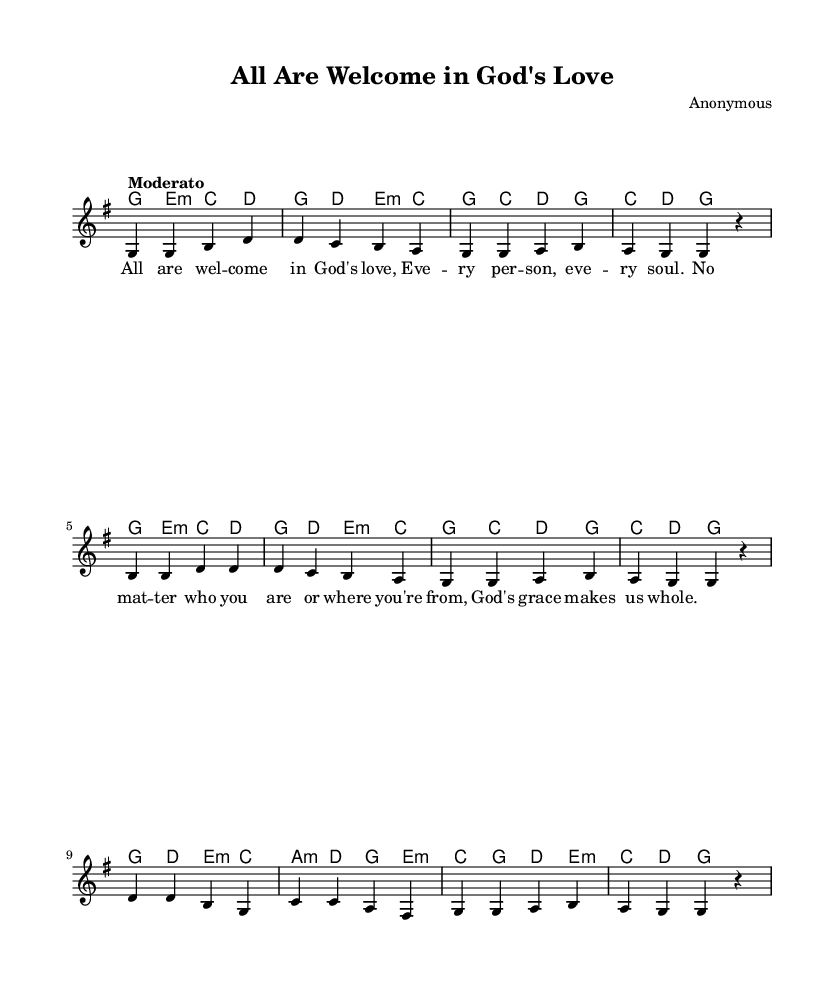What is the key signature of this music? The key signature is G major, indicated by one sharp (F#) which can be counted from the key signature part at the beginning of the score.
Answer: G major What is the time signature of this music? The time signature is 4/4, which is shown at the start of the score and indicates that there are four beats in a measure.
Answer: 4/4 What is the tempo of this piece? The tempo is marked as "Moderato," indicating a moderate speed; it provides a straightforward instruction for performing the piece.
Answer: Moderato How many verses are in the lyrics? The lyrics presented consist of one complete verse, which is shown clearly in the lyric section of the score.
Answer: One What is the first note of the melody? The first note of the melody is G, which can be seen in the melody line as the first note of the sequence.
Answer: G What is the final chord in the harmonies? The final chord in the harmonies is G, which can be identified at the end of the chord line as the last harmonic structure listed in the score.
Answer: G What theme does the lyrics represent? The lyrics promote the theme of inclusion and acceptance, as articulated in the repeated affirmation of welcoming all people regardless of their background.
Answer: Inclusion 